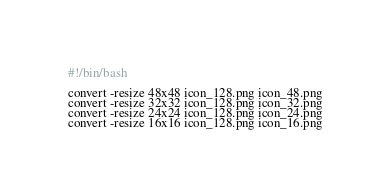Convert code to text. <code><loc_0><loc_0><loc_500><loc_500><_Bash_>#!/bin/bash

convert -resize 48x48 icon_128.png icon_48.png
convert -resize 32x32 icon_128.png icon_32.png
convert -resize 24x24 icon_128.png icon_24.png
convert -resize 16x16 icon_128.png icon_16.png
</code> 